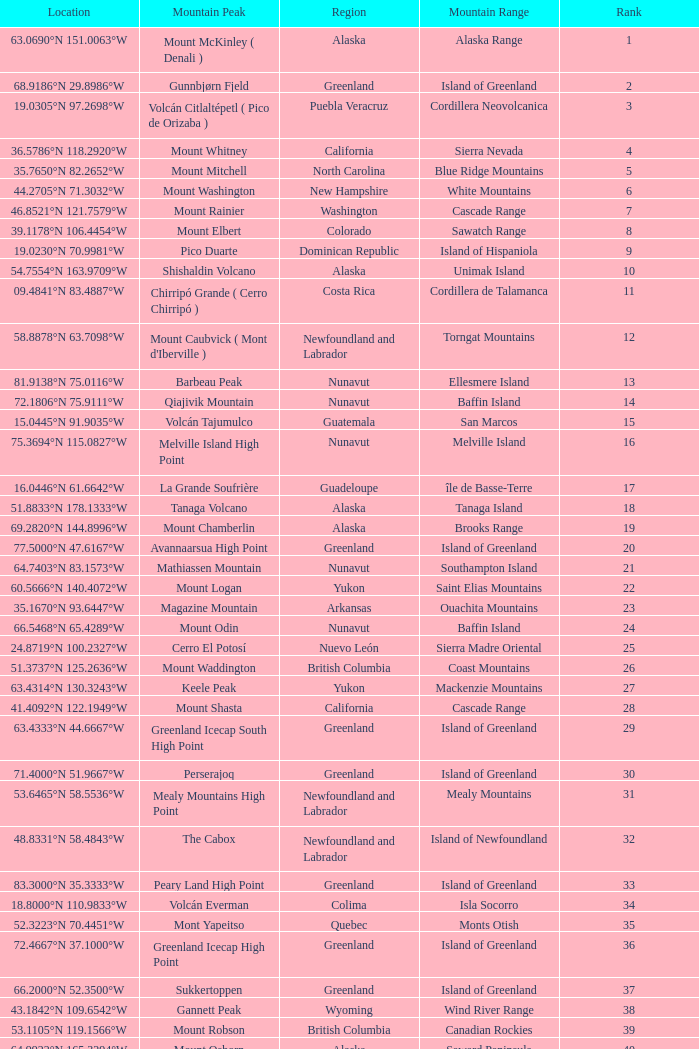Which Mountain Peak has a Region of baja california, and a Location of 28.1301°n 115.2206°w? Isla Cedros High Point. 